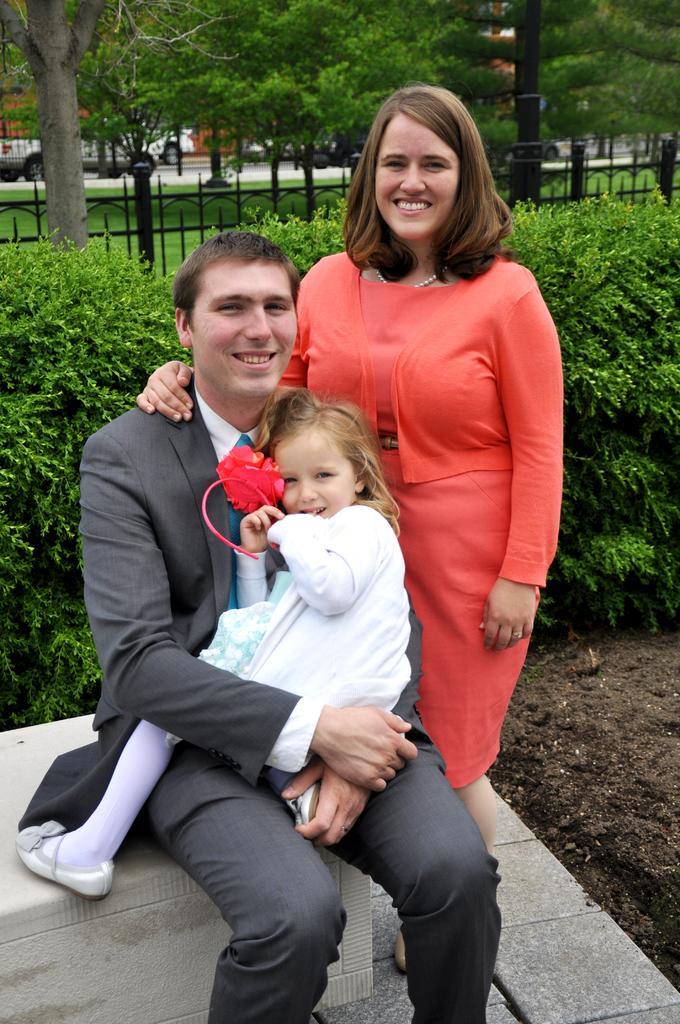Please provide a concise description of this image. In this picture, there is a man sitting on the bench. On his lap, there is a girl. Beside him, there is a woman wearing an orange dress. Man is wearing a blazer and trousers. Behind them, there are plants and fence. In the background there are trees and vehicles. 